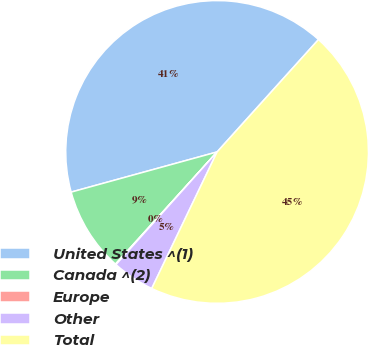Convert chart. <chart><loc_0><loc_0><loc_500><loc_500><pie_chart><fcel>United States ^(1)<fcel>Canada ^(2)<fcel>Europe<fcel>Other<fcel>Total<nl><fcel>40.96%<fcel>9.01%<fcel>0.07%<fcel>4.54%<fcel>45.43%<nl></chart> 